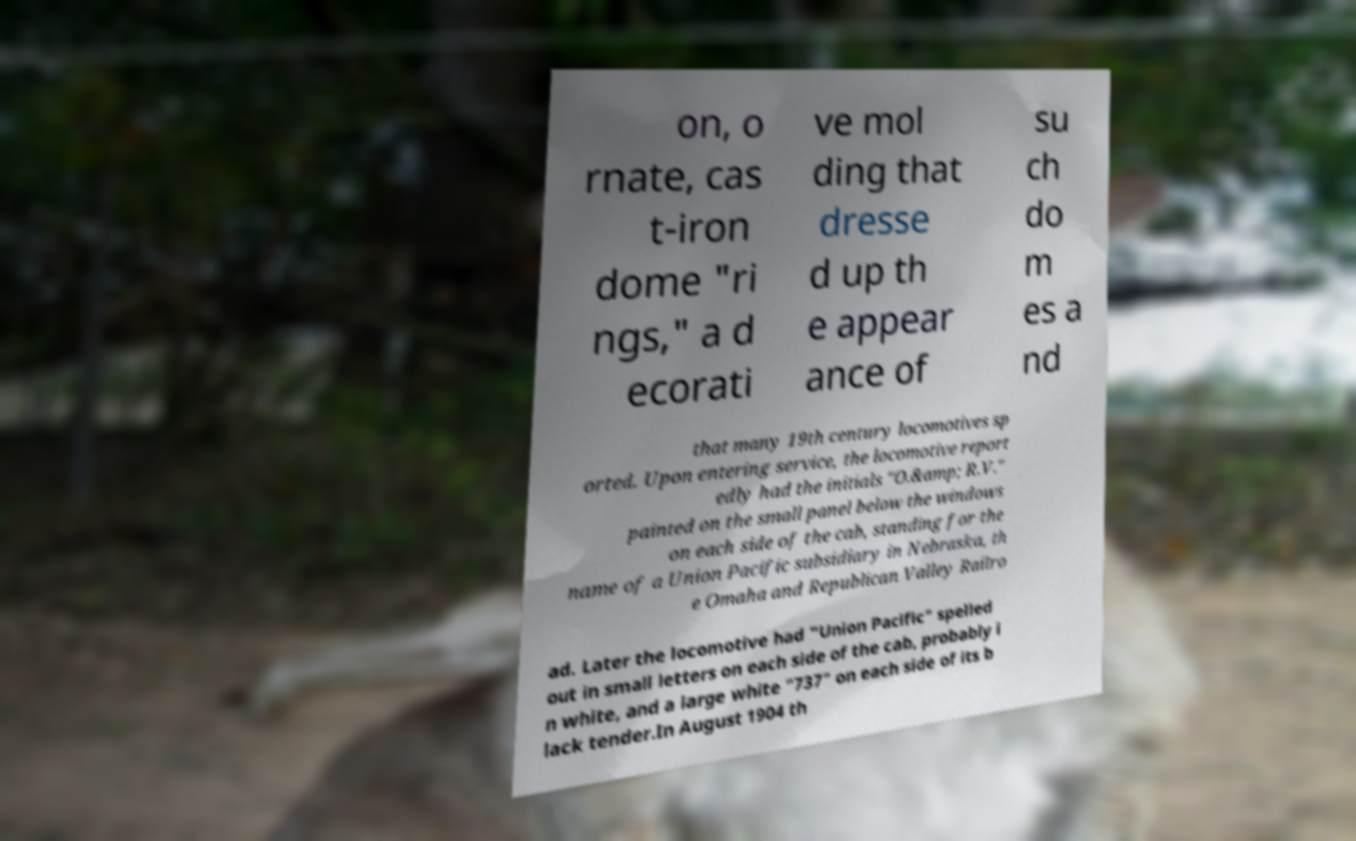Can you accurately transcribe the text from the provided image for me? on, o rnate, cas t-iron dome "ri ngs," a d ecorati ve mol ding that dresse d up th e appear ance of su ch do m es a nd that many 19th century locomotives sp orted. Upon entering service, the locomotive report edly had the initials "O.&amp; R.V." painted on the small panel below the windows on each side of the cab, standing for the name of a Union Pacific subsidiary in Nebraska, th e Omaha and Republican Valley Railro ad. Later the locomotive had "Union Pacific" spelled out in small letters on each side of the cab, probably i n white, and a large white "737" on each side of its b lack tender.In August 1904 th 